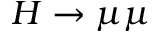<formula> <loc_0><loc_0><loc_500><loc_500>H \to \mu \mu</formula> 